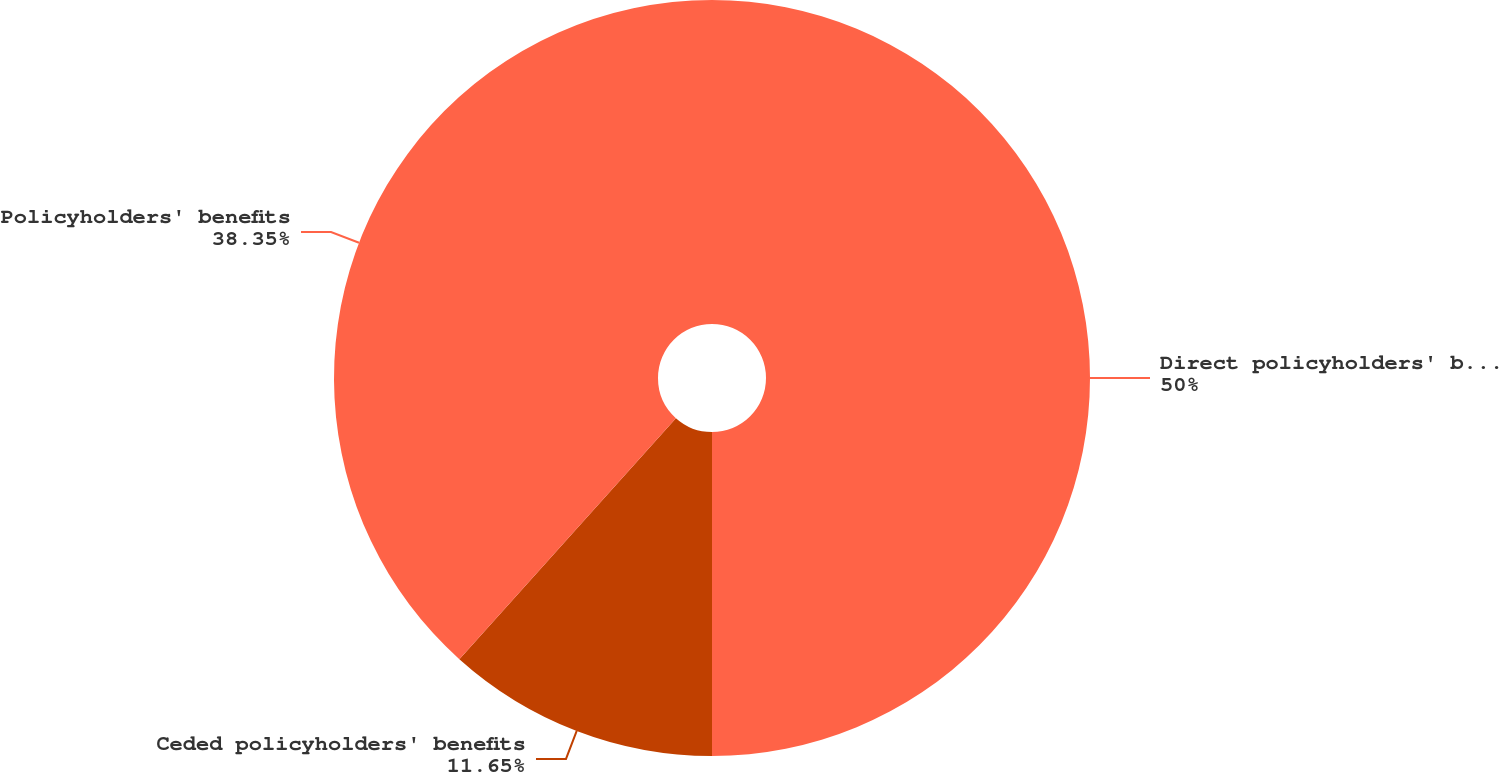Convert chart to OTSL. <chart><loc_0><loc_0><loc_500><loc_500><pie_chart><fcel>Direct policyholders' benefits<fcel>Ceded policyholders' benefits<fcel>Policyholders' benefits<nl><fcel>50.0%<fcel>11.65%<fcel>38.35%<nl></chart> 